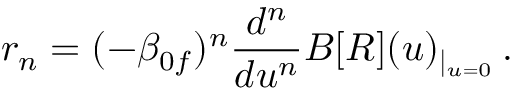<formula> <loc_0><loc_0><loc_500><loc_500>r _ { n } = ( - \beta _ { 0 f } ) ^ { n } \frac { d ^ { n } } { d u ^ { n } } B [ R ] ( u ) _ { | _ { u = 0 } } \, .</formula> 